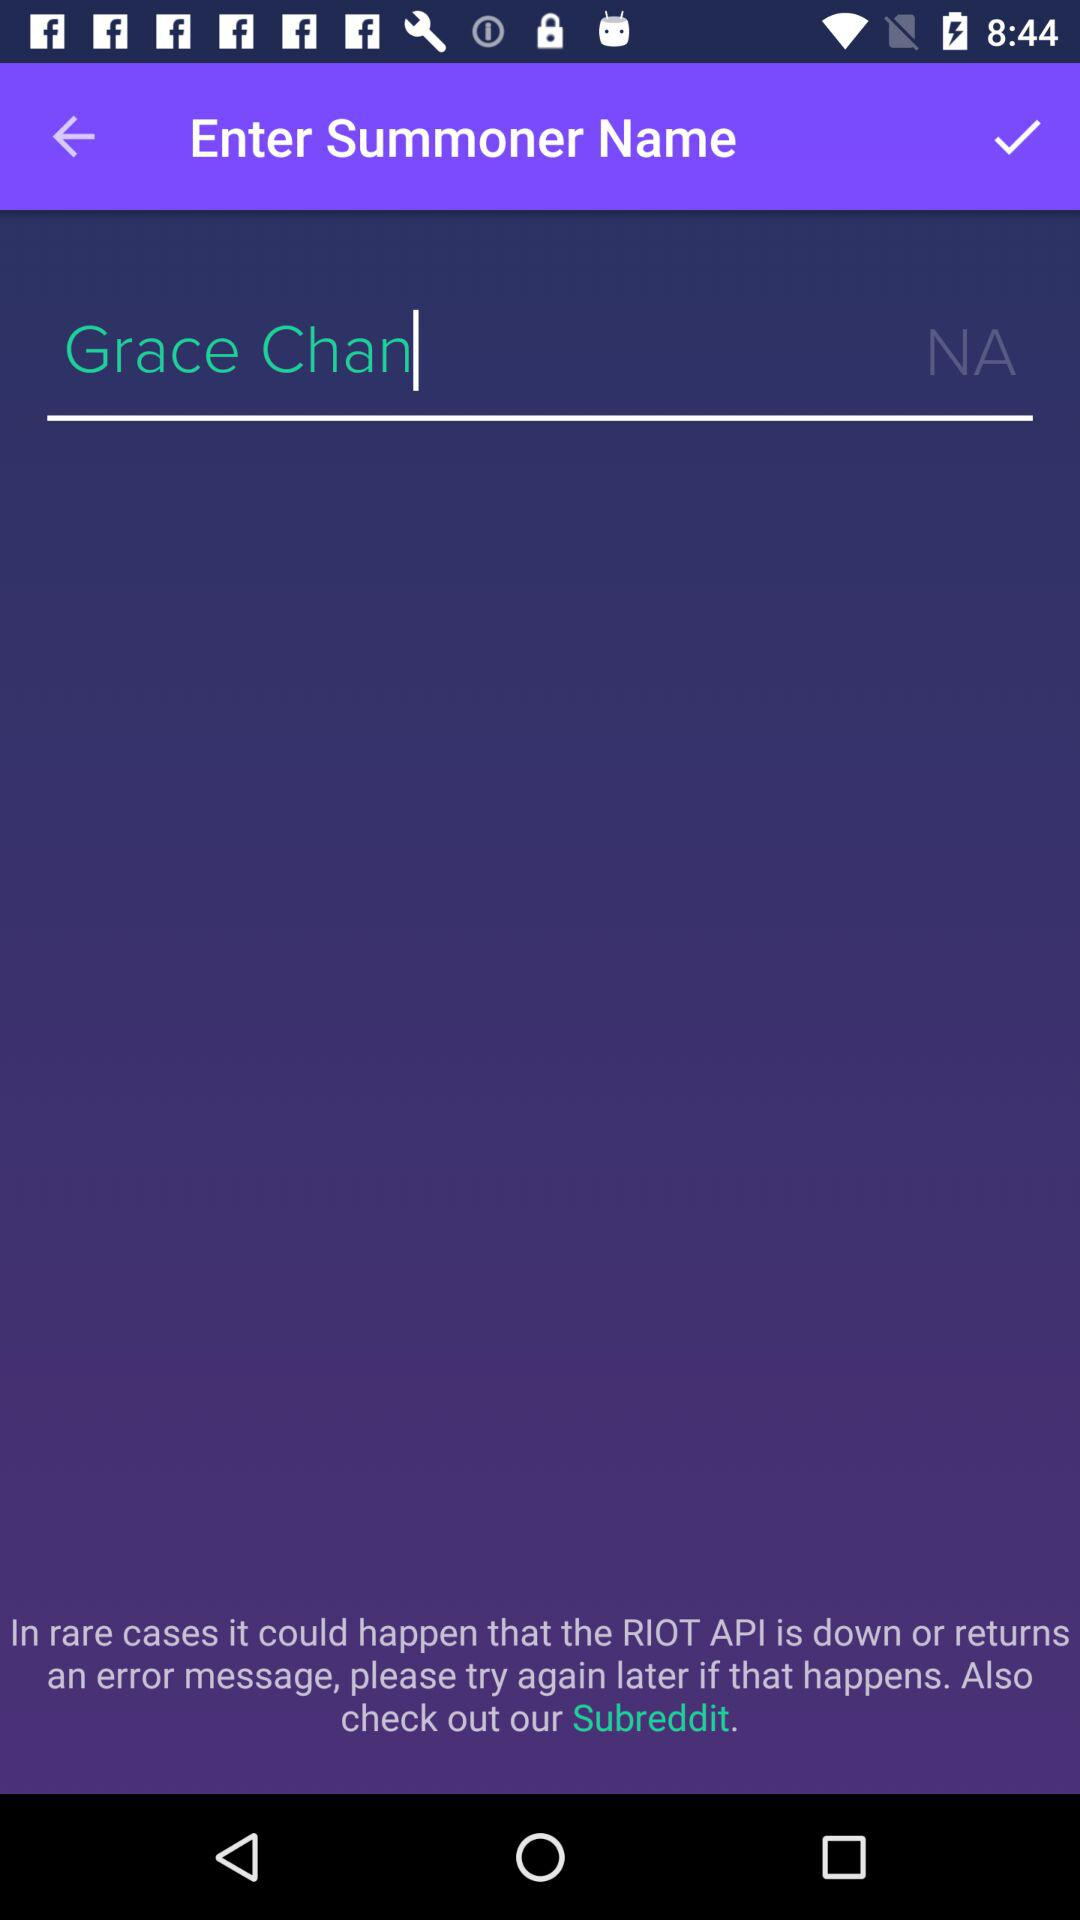What is the name of the summoner that has been entered? The name of the summoner is Grace Chan. 